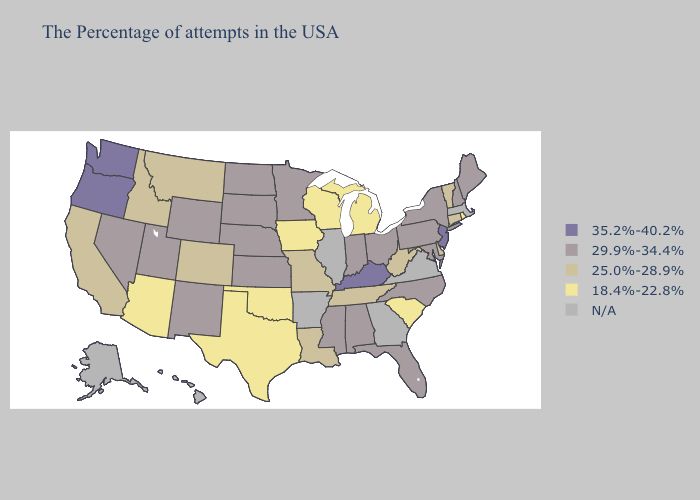What is the lowest value in the West?
Answer briefly. 18.4%-22.8%. Does Oregon have the highest value in the USA?
Quick response, please. Yes. Name the states that have a value in the range N/A?
Answer briefly. Massachusetts, Virginia, Georgia, Illinois, Arkansas, Alaska, Hawaii. Does Arizona have the lowest value in the USA?
Give a very brief answer. Yes. What is the lowest value in the West?
Write a very short answer. 18.4%-22.8%. Does Michigan have the lowest value in the USA?
Answer briefly. Yes. What is the value of New Jersey?
Write a very short answer. 35.2%-40.2%. What is the lowest value in states that border Nevada?
Concise answer only. 18.4%-22.8%. What is the lowest value in states that border Ohio?
Short answer required. 18.4%-22.8%. Among the states that border Montana , does South Dakota have the highest value?
Give a very brief answer. Yes. Among the states that border Michigan , which have the lowest value?
Give a very brief answer. Wisconsin. What is the lowest value in states that border Connecticut?
Answer briefly. 18.4%-22.8%. What is the highest value in states that border Mississippi?
Keep it brief. 29.9%-34.4%. Does Texas have the highest value in the USA?
Give a very brief answer. No. 